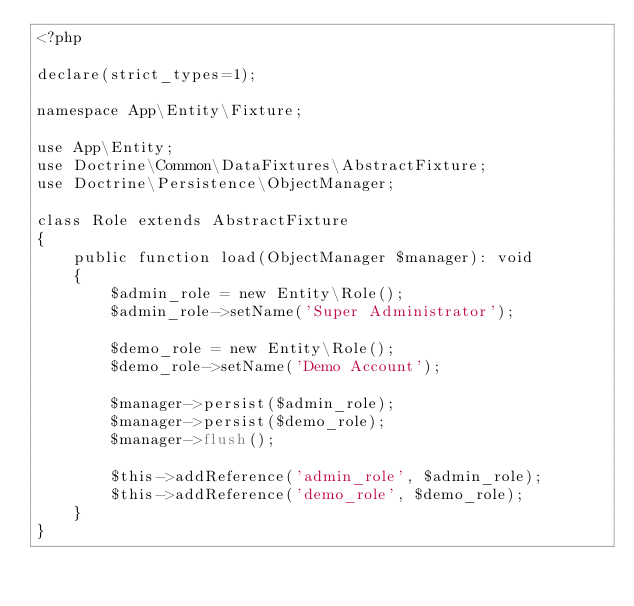<code> <loc_0><loc_0><loc_500><loc_500><_PHP_><?php

declare(strict_types=1);

namespace App\Entity\Fixture;

use App\Entity;
use Doctrine\Common\DataFixtures\AbstractFixture;
use Doctrine\Persistence\ObjectManager;

class Role extends AbstractFixture
{
    public function load(ObjectManager $manager): void
    {
        $admin_role = new Entity\Role();
        $admin_role->setName('Super Administrator');

        $demo_role = new Entity\Role();
        $demo_role->setName('Demo Account');

        $manager->persist($admin_role);
        $manager->persist($demo_role);
        $manager->flush();

        $this->addReference('admin_role', $admin_role);
        $this->addReference('demo_role', $demo_role);
    }
}
</code> 